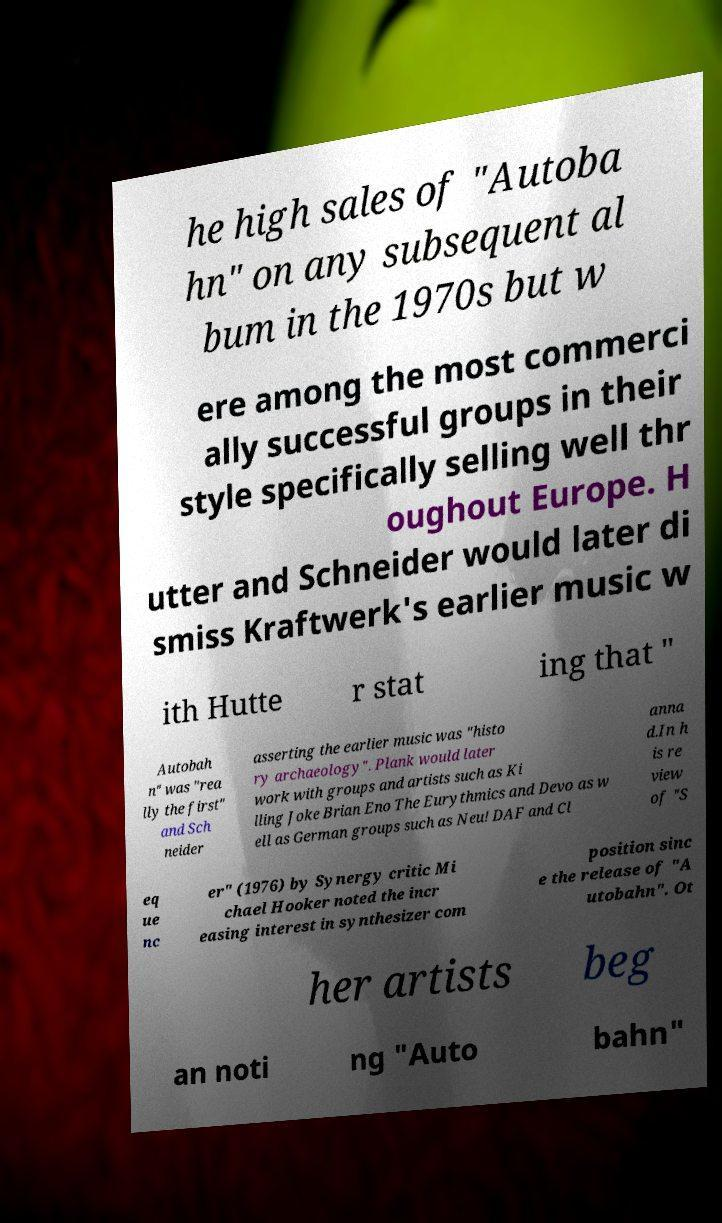There's text embedded in this image that I need extracted. Can you transcribe it verbatim? he high sales of "Autoba hn" on any subsequent al bum in the 1970s but w ere among the most commerci ally successful groups in their style specifically selling well thr oughout Europe. H utter and Schneider would later di smiss Kraftwerk's earlier music w ith Hutte r stat ing that " Autobah n" was "rea lly the first" and Sch neider asserting the earlier music was "histo ry archaeology". Plank would later work with groups and artists such as Ki lling Joke Brian Eno The Eurythmics and Devo as w ell as German groups such as Neu! DAF and Cl anna d.In h is re view of "S eq ue nc er" (1976) by Synergy critic Mi chael Hooker noted the incr easing interest in synthesizer com position sinc e the release of "A utobahn". Ot her artists beg an noti ng "Auto bahn" 